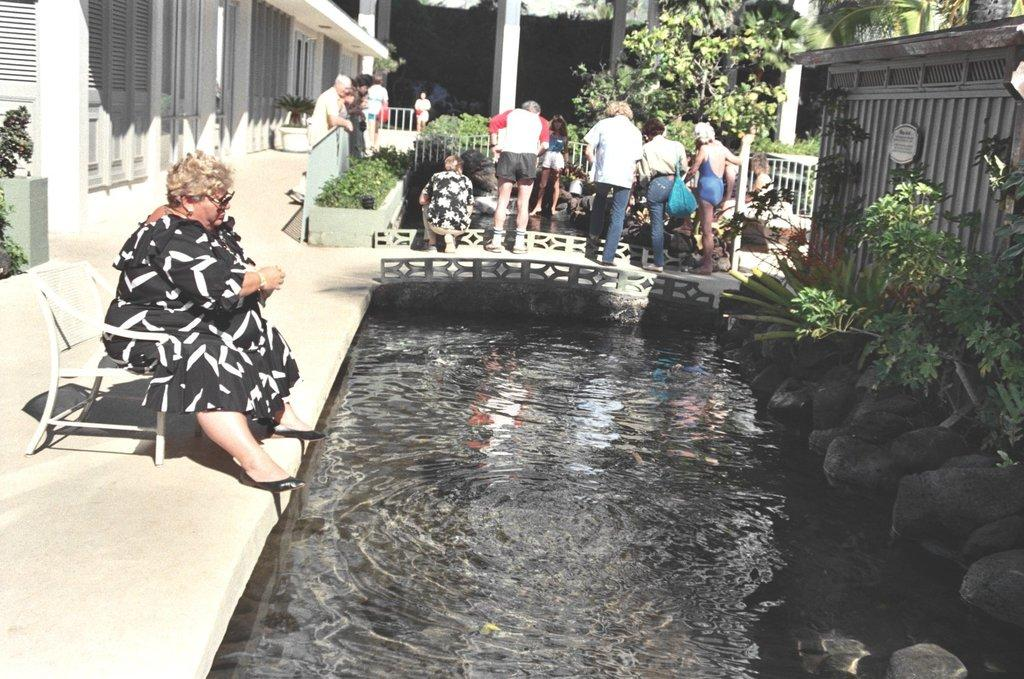How many people are in the image? There are people in the image, but the exact number is not specified. What are some of the positions of the people in the image? Some people are standing, and some people are sitting. What type of natural elements can be seen in the image? Water, plants, and trees are visible in the image. What type of man-made structures can be seen in the image? There is a fence and doors visible in the image. Are there any other objects present in the image? Yes, there are other objects in the image. What type of badge is being worn by the person in the image? There is no mention of a badge in the image, so it cannot be determined if anyone is wearing one. How does the flight of the birds in the image affect the people's behavior? There are no birds mentioned in the image, so their flight cannot affect the people's behavior. 